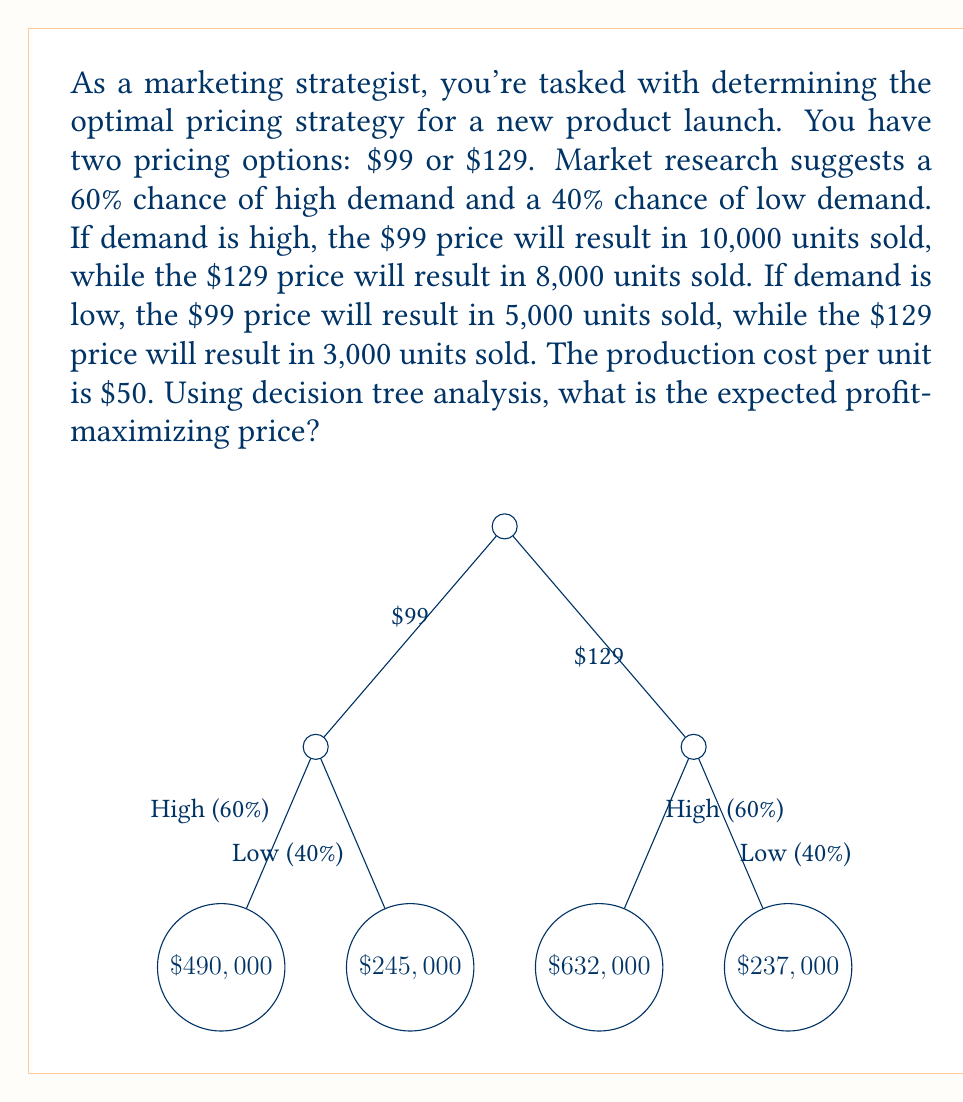Show me your answer to this math problem. Let's solve this problem step by step using decision tree analysis:

1) First, calculate the profit for each scenario:

   For $\$99$ price:
   - High demand: $10,000 \times (\$99 - \$50) = \$490,000$
   - Low demand: $5,000 \times (\$99 - \$50) = \$245,000$

   For $\$129$ price:
   - High demand: $8,000 \times (\$129 - \$50) = \$632,000$
   - Low demand: $3,000 \times (\$129 - \$50) = \$237,000$

2) Now, calculate the expected value (EV) for each pricing strategy:

   For $\$99$ price:
   $$EV_{99} = 0.6 \times \$490,000 + 0.4 \times \$245,000 = \$392,000$$

   For $\$129$ price:
   $$EV_{129} = 0.6 \times \$632,000 + 0.4 \times \$237,000 = \$474,000$$

3) Compare the expected values:

   $EV_{129} > EV_{99}$, so the $\$129$ price maximizes expected profit.
Answer: $\$129$ 